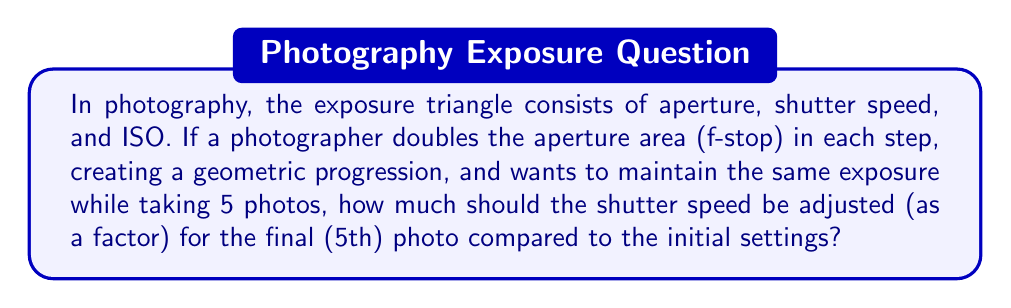Show me your answer to this math problem. Let's approach this step-by-step:

1) In the exposure triangle, when one factor is changed, another must be adjusted to maintain the same exposure. In this case, as aperture increases, shutter speed must decrease.

2) The aperture area forms a geometric progression with a common ratio of 2. This can be represented as:

   $$a, 2a, 4a, 8a, 16a$$

   where $a$ is the initial aperture area.

3) To maintain the same exposure, the shutter speed must form a geometric progression with the reciprocal of the aperture progression:

   $$s, \frac{s}{2}, \frac{s}{4}, \frac{s}{8}, \frac{s}{16}$$

   where $s$ is the initial shutter speed.

4) We're interested in the ratio between the final and initial shutter speeds. This is given by the last term of the shutter speed progression:

   $$\frac{\text{Final shutter speed}}{\text{Initial shutter speed}} = \frac{s/16}{s} = \frac{1}{16}$$

5) Therefore, the shutter speed for the 5th photo should be $\frac{1}{16}$ of the initial shutter speed.
Answer: $\frac{1}{16}$ 